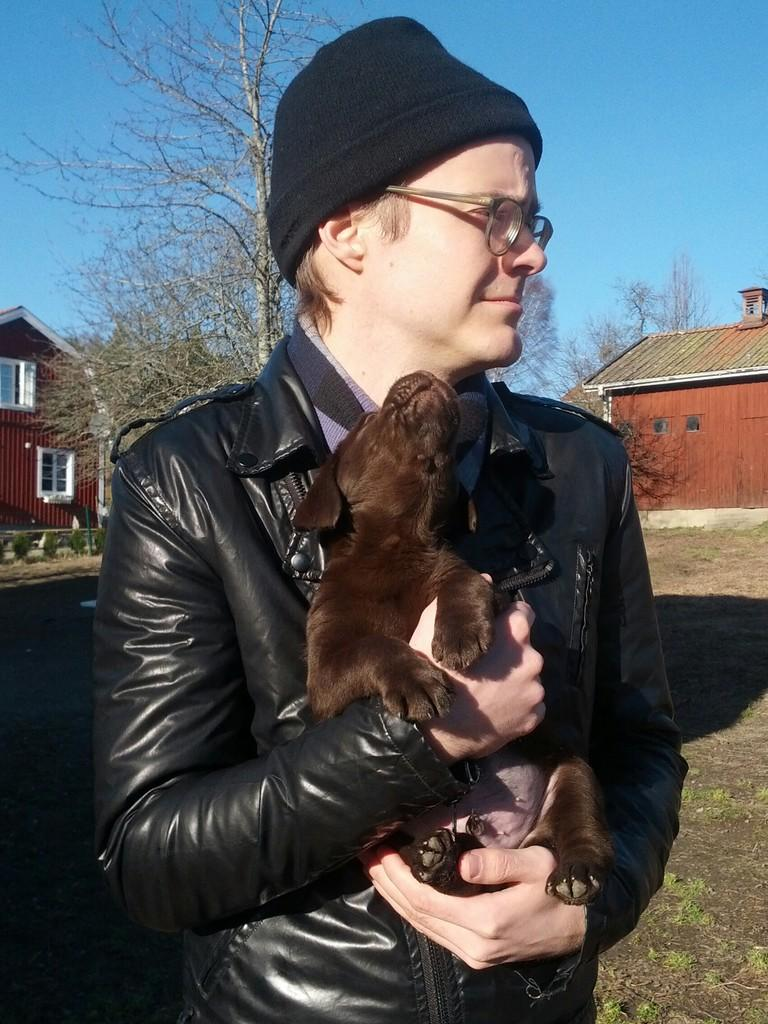What is the main subject of the image? The main subject of the image is a man. What is the man wearing? The man is wearing a jacket, spectacles, and a cap. What is the man holding in the image? The man is holding a dog with his hand. What is the man's facial expression? The man is smiling. What can be seen in the background of the image? There is a tree, houses with windows, and the sky visible in the background of the image. Can you tell me where the key is located in the image? There is no key present in the image. Is there a river visible in the image? No, there is no river visible in the image. 